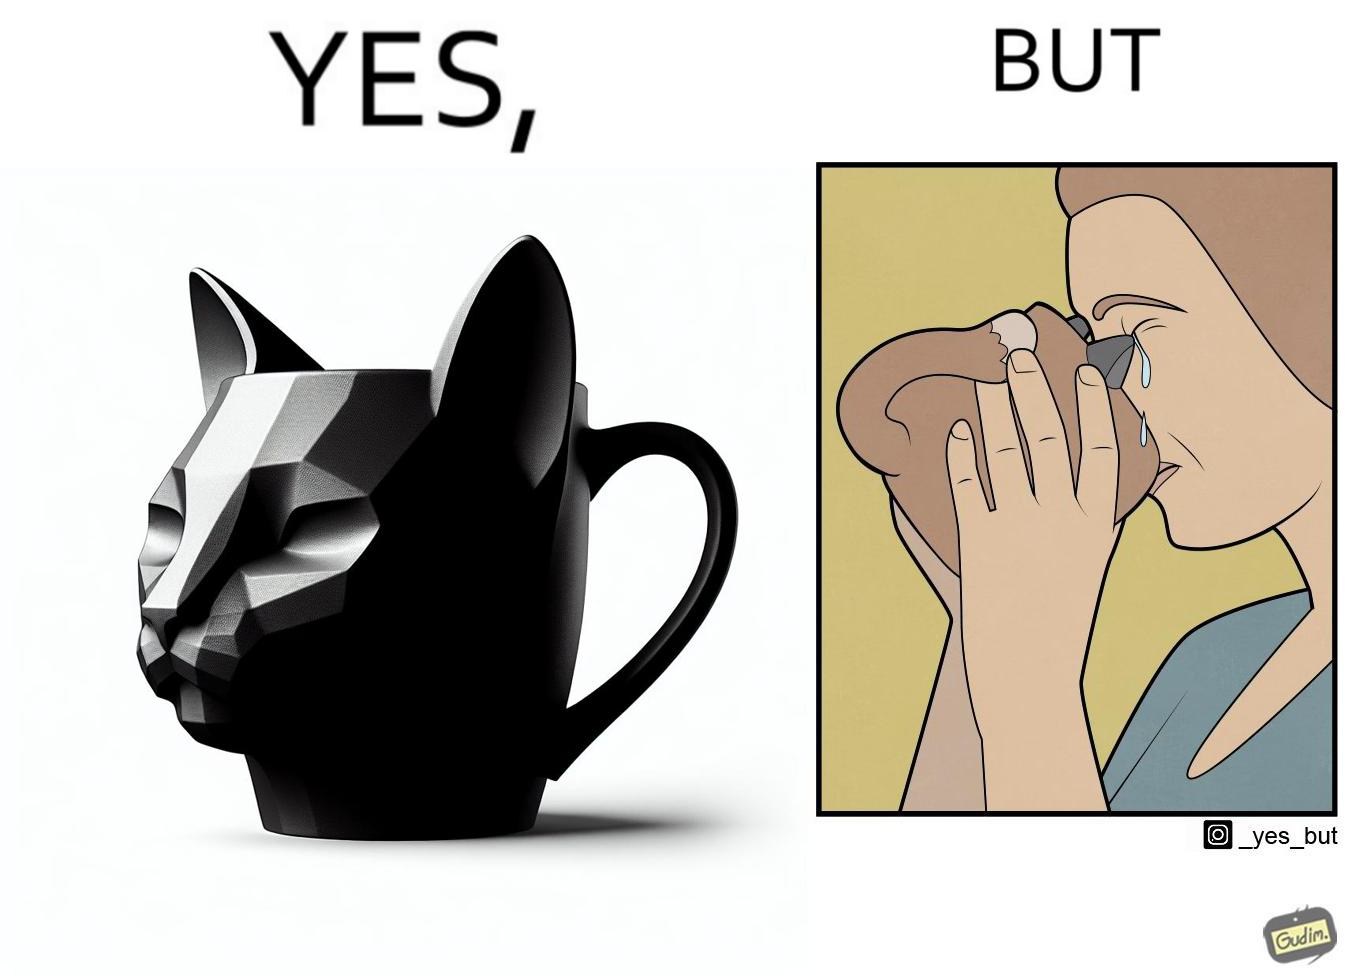What is the satirical meaning behind this image? The irony in the image is that the mug is supposedly cute and quirky but it is completely impractical as a mug as it will hurt its user. 